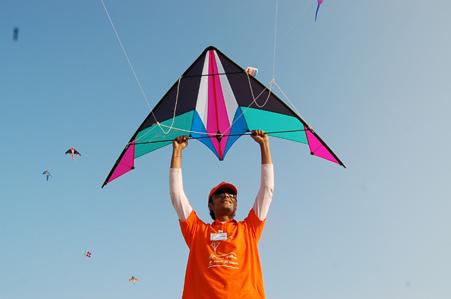What is this man doing?
Concise answer only. Flying kite. What color is the man's shirt?
Short answer required. Orange. How many kites are visible?
Quick response, please. 7. 